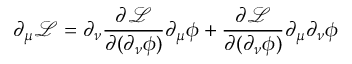<formula> <loc_0><loc_0><loc_500><loc_500>\partial _ { \mu } { \mathcal { L } } = \partial _ { \nu } { \frac { \partial { \mathcal { L } } } { \partial ( \partial _ { \nu } \phi ) } } \partial _ { \mu } \phi + { \frac { \partial { \mathcal { L } } } { \partial ( \partial _ { \nu } \phi ) } } \partial _ { \mu } \partial _ { \nu } \phi</formula> 